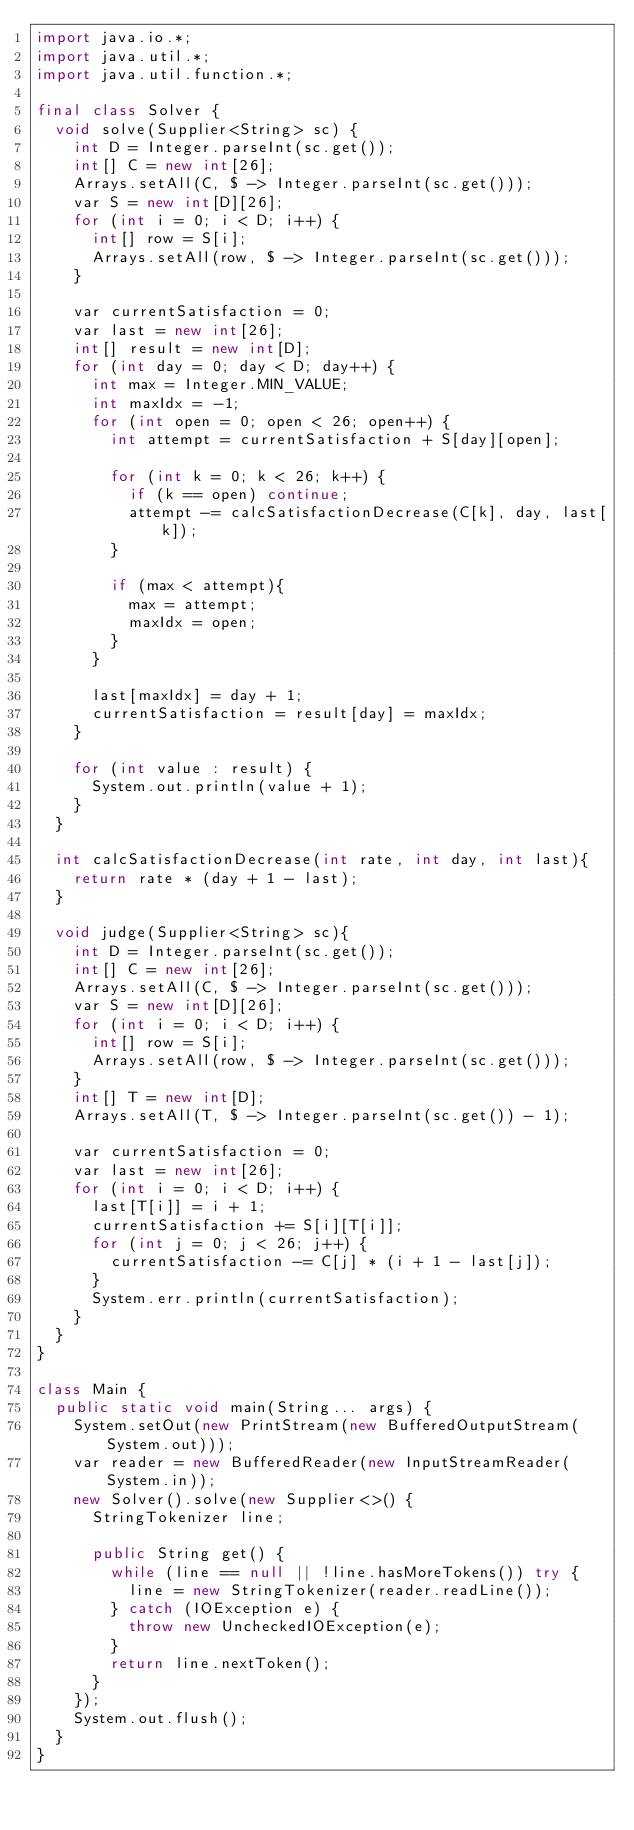Convert code to text. <code><loc_0><loc_0><loc_500><loc_500><_Java_>import java.io.*;
import java.util.*;
import java.util.function.*;

final class Solver {
	void solve(Supplier<String> sc) {
		int D = Integer.parseInt(sc.get());
		int[] C = new int[26];
		Arrays.setAll(C, $ -> Integer.parseInt(sc.get()));
		var S = new int[D][26];
		for (int i = 0; i < D; i++) {
			int[] row = S[i];
			Arrays.setAll(row, $ -> Integer.parseInt(sc.get()));
		}

		var currentSatisfaction = 0;
		var last = new int[26];
		int[] result = new int[D];
		for (int day = 0; day < D; day++) {
			int max = Integer.MIN_VALUE;
			int maxIdx = -1;
			for (int open = 0; open < 26; open++) {
				int attempt = currentSatisfaction + S[day][open];

				for (int k = 0; k < 26; k++) {
					if (k == open) continue;
					attempt -= calcSatisfactionDecrease(C[k], day, last[k]);
				}

				if (max < attempt){
					max = attempt;
					maxIdx = open;
				}
			}

			last[maxIdx] = day + 1;
			currentSatisfaction = result[day] = maxIdx;
		}

		for (int value : result) {
			System.out.println(value + 1);
		}
	}

	int calcSatisfactionDecrease(int rate, int day, int last){
		return rate * (day + 1 - last);
	}

	void judge(Supplier<String> sc){
		int D = Integer.parseInt(sc.get());
		int[] C = new int[26];
		Arrays.setAll(C, $ -> Integer.parseInt(sc.get()));
		var S = new int[D][26];
		for (int i = 0; i < D; i++) {
			int[] row = S[i];
			Arrays.setAll(row, $ -> Integer.parseInt(sc.get()));
		}
		int[] T = new int[D];
		Arrays.setAll(T, $ -> Integer.parseInt(sc.get()) - 1);

		var currentSatisfaction = 0;
		var last = new int[26];
		for (int i = 0; i < D; i++) {
			last[T[i]] = i + 1;
			currentSatisfaction += S[i][T[i]];
			for (int j = 0; j < 26; j++) {
				currentSatisfaction -= C[j] * (i + 1 - last[j]);
			}
			System.err.println(currentSatisfaction);
		}
	}
}

class Main {
	public static void main(String... args) {
		System.setOut(new PrintStream(new BufferedOutputStream(System.out)));
		var reader = new BufferedReader(new InputStreamReader(System.in));
		new Solver().solve(new Supplier<>() {
			StringTokenizer line;

			public String get() {
				while (line == null || !line.hasMoreTokens()) try {
					line = new StringTokenizer(reader.readLine());
				} catch (IOException e) {
					throw new UncheckedIOException(e);
				}
				return line.nextToken();
			}
		});
		System.out.flush();
	}
}</code> 